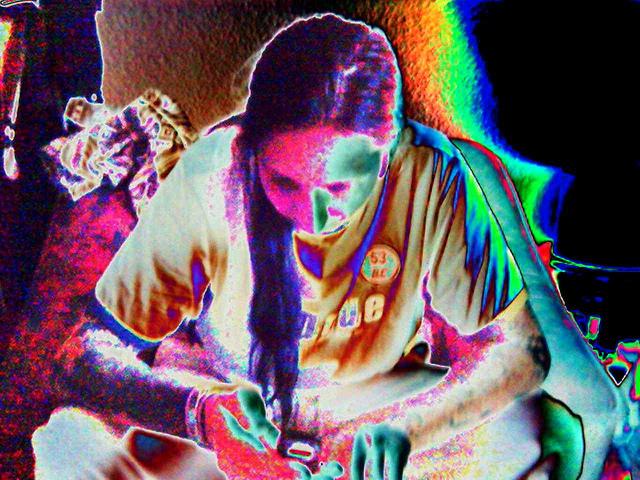Is the picture overexposed?
Concise answer only. Yes. Does the person have long or short hair?
Give a very brief answer. Long. What is the man doing?
Concise answer only. Texting. 